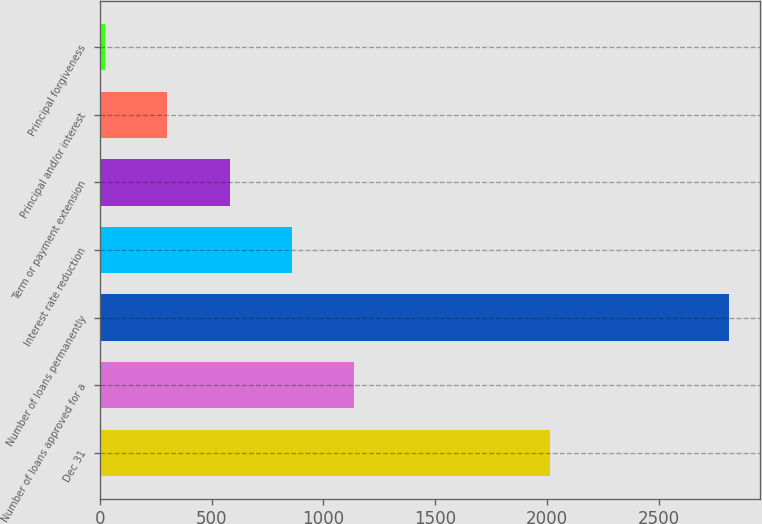Convert chart. <chart><loc_0><loc_0><loc_500><loc_500><bar_chart><fcel>Dec 31<fcel>Number of loans approved for a<fcel>Number of loans permanently<fcel>Interest rate reduction<fcel>Term or payment extension<fcel>Principal and/or interest<fcel>Principal forgiveness<nl><fcel>2014<fcel>1138.4<fcel>2813<fcel>859.3<fcel>580.2<fcel>301.1<fcel>22<nl></chart> 